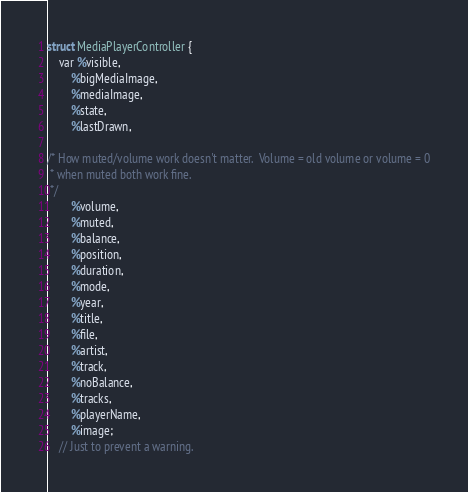Convert code to text. <code><loc_0><loc_0><loc_500><loc_500><_C_>struct MediaPlayerController {
	var %visible,
		%bigMediaImage,
		%mediaImage,
		%state,
		%lastDrawn,

/* How muted/volume work doesn't matter.  Volume = old volume or volume = 0
 * when muted both work fine.
 */
		%volume,
		%muted,
		%balance,
		%position,
		%duration,
		%mode,
		%year,
		%title,
		%file,
		%artist,
		%track,
		%noBalance,
		%tracks,
		%playerName,
		%image;
	// Just to prevent a warning.</code> 